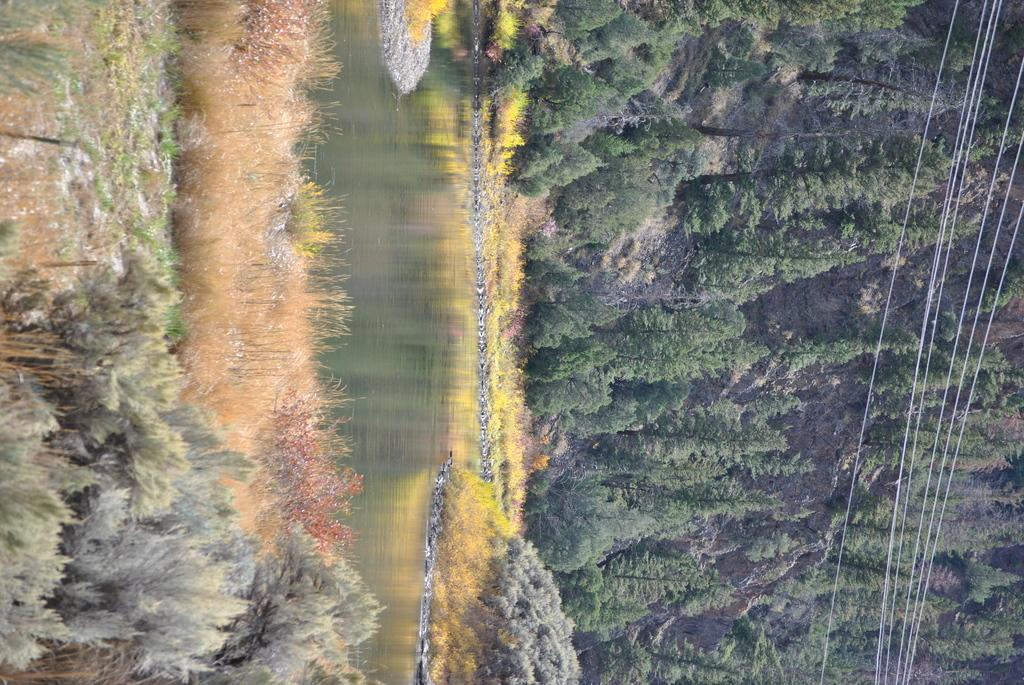What type of vegetation is on the right side of the image? There are trees on the right side of the image. What else can be seen on the right side of the image? There are cables on the right side of the image. What is in the middle of the image? There is water in the middle of the image. What type of vegetation is at the bottom of the image? There are plants at the bottom of the image. What else is at the bottom of the image? There is grass and land at the bottom of the image. What type of feather can be seen floating in the water in the image? There is no feather present in the image; it only features trees, cables, water, plants, grass, and land. What type of soda is being served in the image? There is no soda present in the image; it only features trees, cables, water, plants, grass, and land. 